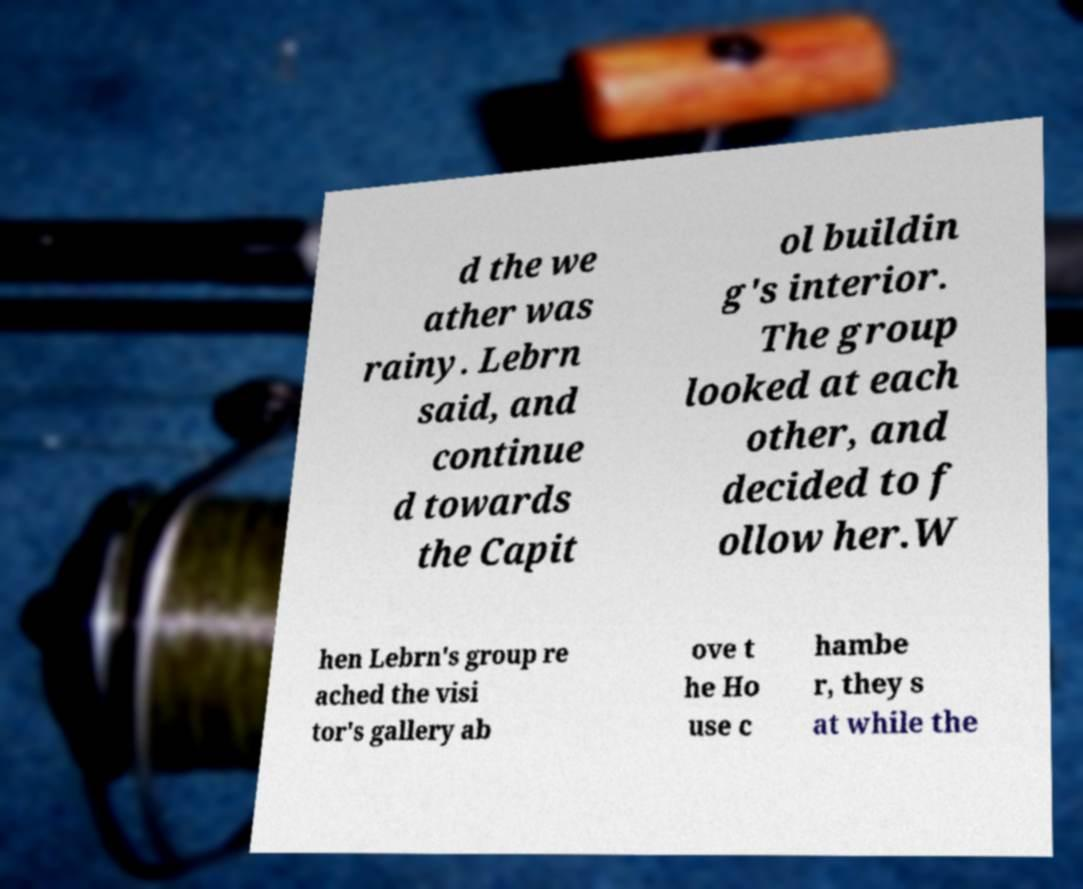Can you read and provide the text displayed in the image?This photo seems to have some interesting text. Can you extract and type it out for me? d the we ather was rainy. Lebrn said, and continue d towards the Capit ol buildin g's interior. The group looked at each other, and decided to f ollow her.W hen Lebrn's group re ached the visi tor's gallery ab ove t he Ho use c hambe r, they s at while the 